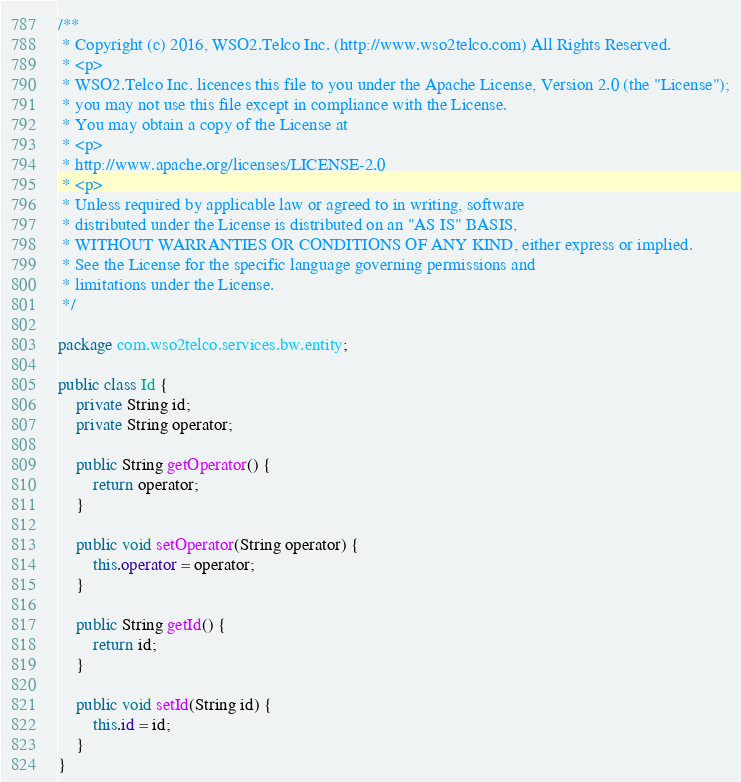<code> <loc_0><loc_0><loc_500><loc_500><_Java_>/**
 * Copyright (c) 2016, WSO2.Telco Inc. (http://www.wso2telco.com) All Rights Reserved.
 * <p>
 * WSO2.Telco Inc. licences this file to you under the Apache License, Version 2.0 (the "License");
 * you may not use this file except in compliance with the License.
 * You may obtain a copy of the License at
 * <p>
 * http://www.apache.org/licenses/LICENSE-2.0
 * <p>
 * Unless required by applicable law or agreed to in writing, software
 * distributed under the License is distributed on an "AS IS" BASIS,
 * WITHOUT WARRANTIES OR CONDITIONS OF ANY KIND, either express or implied.
 * See the License for the specific language governing permissions and
 * limitations under the License.
 */

package com.wso2telco.services.bw.entity;

public class Id {
    private String id;
    private String operator;

    public String getOperator() {
        return operator;
    }

    public void setOperator(String operator) {
        this.operator = operator;
    }

    public String getId() {
        return id;
    }

    public void setId(String id) {
        this.id = id;
    }
}
</code> 